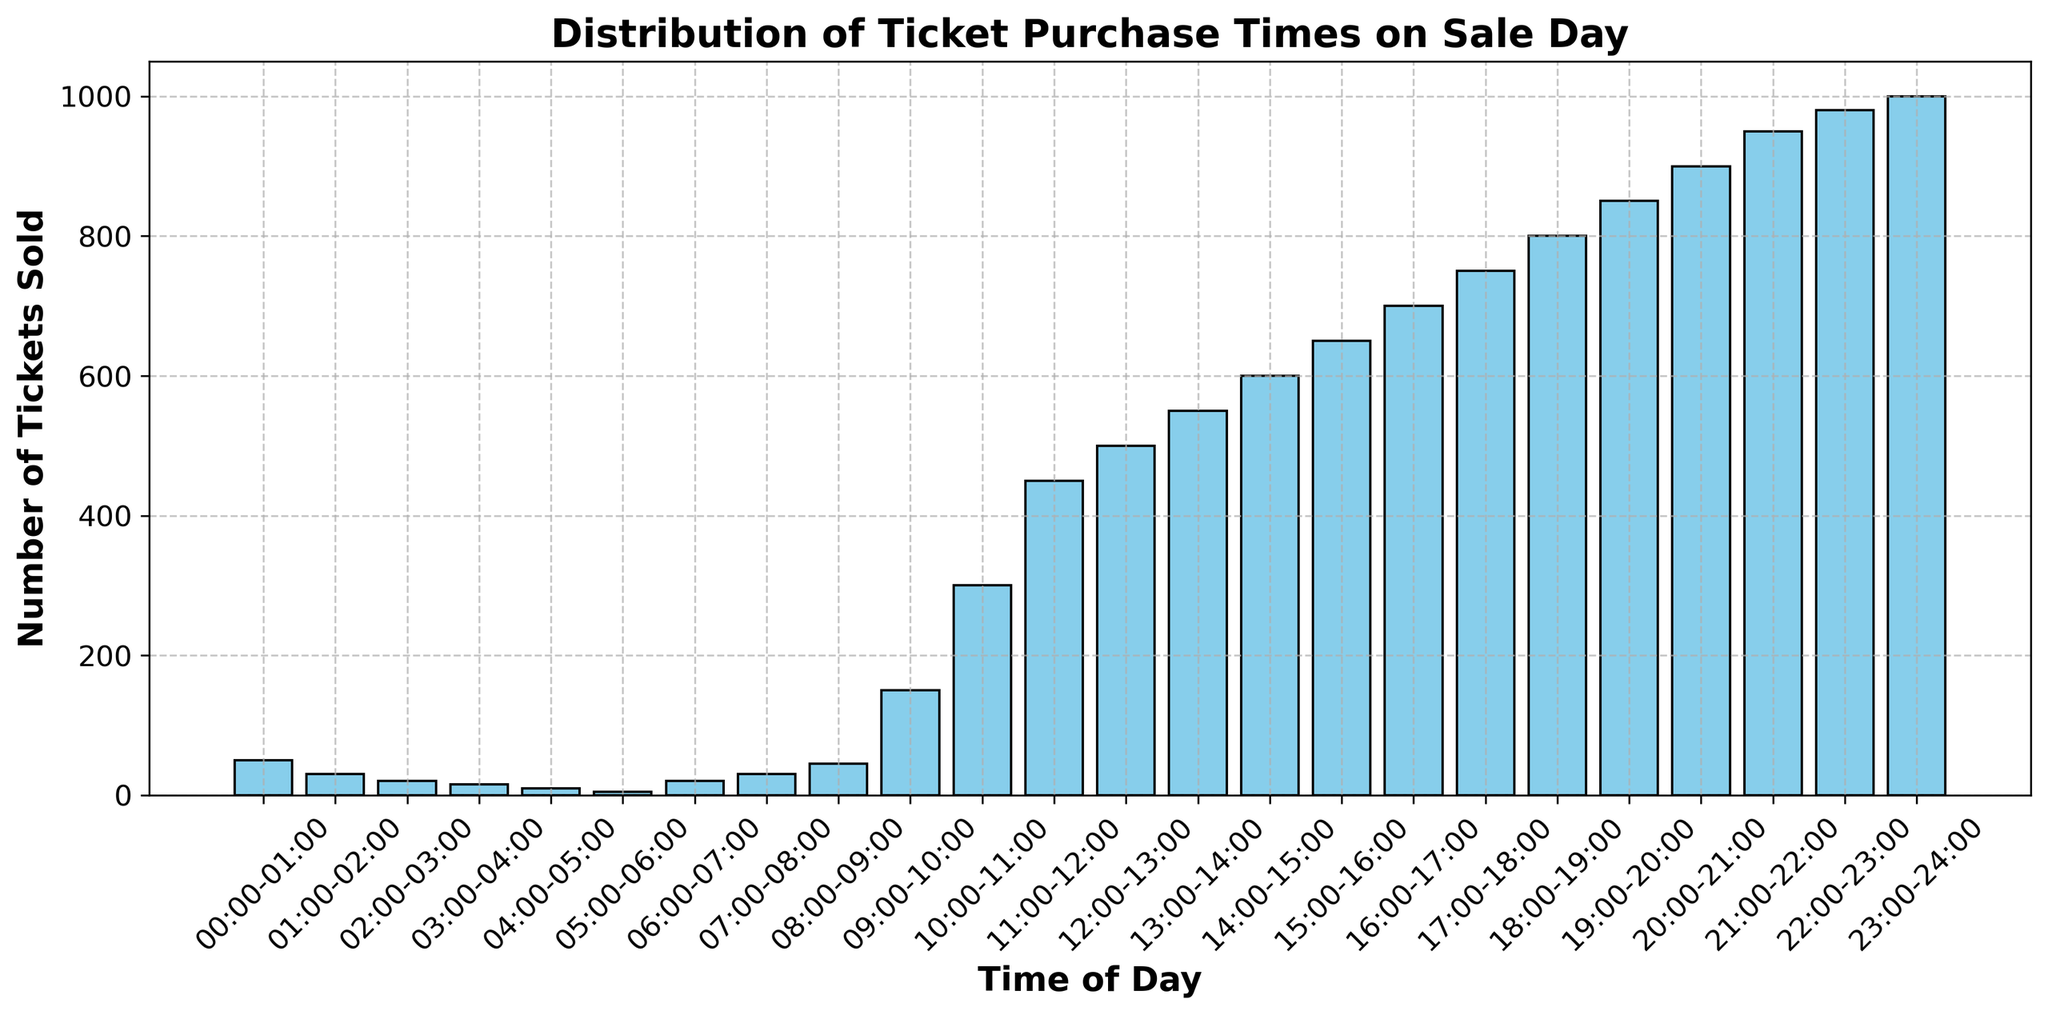What hour has the highest number of ticket sales? By examining the histogram, the highest bar indicates the hour with the most ticket sales, which is 23:00-24:00 with 1000 tickets sold.
Answer: 23:00-24:00 During which hour does the number of ticket sales first exceed 500? Looking at the histogram, the first bar that exceeds the 500-mark is the one corresponding to the time interval 13:00-14:00.
Answer: 13:00-14:00 What is the total number of tickets sold between 12:00-14:00? To find the total number of tickets sold between 12:00-14:00, sum the counts for the hours 12:00-13:00 and 13:00-14:00: 500 + 550 = 1050.
Answer: 1050 What is the difference in ticket sales between 18:00-19:00 and 08:00-09:00? Subtract the number of tickets sold between 08:00-09:00 from the number sold between 18:00-19:00: 800 - 45 = 755.
Answer: 755 How many tickets were sold in total during the first six hours of the day? Sum the counts of tickets sold from 00:00-06:00: 50 + 30 + 20 + 15 + 10 + 5 = 130
Answer: 130 Which time interval shows a sharp increase in ticket sales compared to the previous hour's sales before noon? Identify the time interval with the highest increase in ticket sales compared to the previous one before noon. From 09:00-10:00 to 10:00-11:00, sales increase from 150 to 300, which is the sharpest increase.
Answer: 10:00-11:00 What is the average number of tickets sold per hour between 16:00 and 18:00? Sum the ticket counts for 16:00-17:00, 17:00-18:00 and divide by the number of hours: (700 + 750) / 2 = 725.
Answer: 725 Compare the sales between the time intervals 09:00-12:00 and 18:00-21:00. Which period had more sales? Sum the sales for the periods 09:00-12:00 and 18:00-21:00. For 09:00-12:00: 150 + 300 + 450 = 900. For 18:00-21:00: 800 + 850 + 900 = 2550. The period 18:00-21:00 had more sales.
Answer: 18:00-21:00 At what time of the day do ticket sales start to significantly increase? Observing the histogram, sales start to significantly increase around 09:00-10:00 and continue to rise steadily.
Answer: 09:00-10:00 